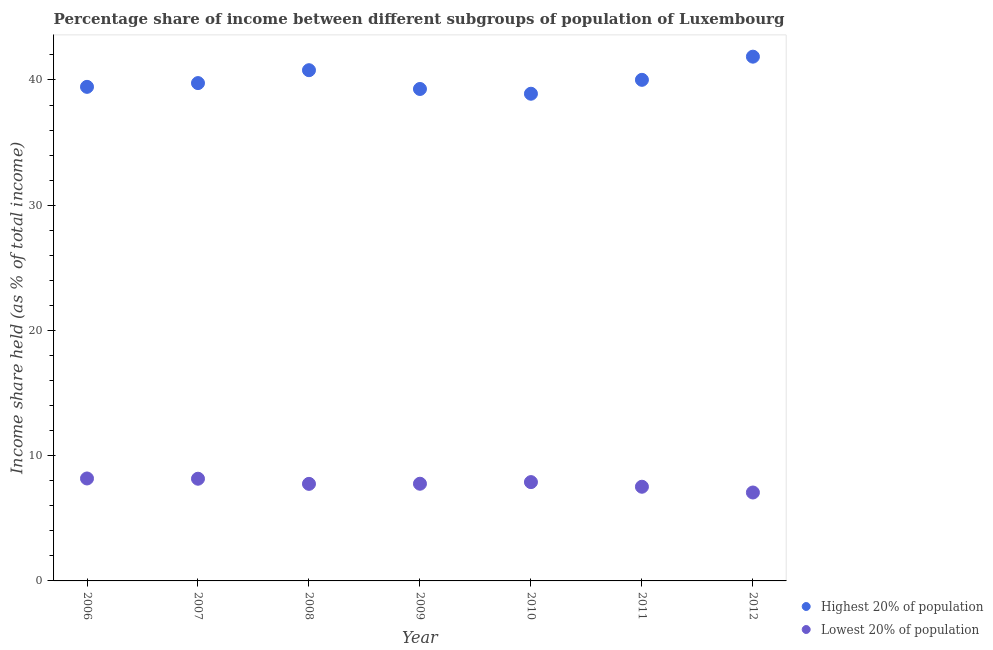What is the income share held by lowest 20% of the population in 2012?
Make the answer very short. 7.06. Across all years, what is the maximum income share held by lowest 20% of the population?
Offer a very short reply. 8.18. Across all years, what is the minimum income share held by highest 20% of the population?
Offer a terse response. 38.9. In which year was the income share held by highest 20% of the population maximum?
Your answer should be compact. 2012. In which year was the income share held by highest 20% of the population minimum?
Provide a short and direct response. 2010. What is the total income share held by highest 20% of the population in the graph?
Your response must be concise. 280.03. What is the difference between the income share held by lowest 20% of the population in 2010 and that in 2011?
Your answer should be compact. 0.37. What is the difference between the income share held by lowest 20% of the population in 2007 and the income share held by highest 20% of the population in 2008?
Keep it short and to the point. -32.62. What is the average income share held by highest 20% of the population per year?
Make the answer very short. 40. In the year 2006, what is the difference between the income share held by highest 20% of the population and income share held by lowest 20% of the population?
Your answer should be compact. 31.27. What is the ratio of the income share held by highest 20% of the population in 2007 to that in 2011?
Keep it short and to the point. 0.99. What is the difference between the highest and the second highest income share held by lowest 20% of the population?
Make the answer very short. 0.02. What is the difference between the highest and the lowest income share held by highest 20% of the population?
Offer a very short reply. 2.96. In how many years, is the income share held by highest 20% of the population greater than the average income share held by highest 20% of the population taken over all years?
Provide a short and direct response. 3. Does the income share held by highest 20% of the population monotonically increase over the years?
Your response must be concise. No. Is the income share held by highest 20% of the population strictly greater than the income share held by lowest 20% of the population over the years?
Give a very brief answer. Yes. Is the income share held by lowest 20% of the population strictly less than the income share held by highest 20% of the population over the years?
Your answer should be compact. Yes. What is the difference between two consecutive major ticks on the Y-axis?
Provide a short and direct response. 10. Are the values on the major ticks of Y-axis written in scientific E-notation?
Offer a very short reply. No. Does the graph contain any zero values?
Ensure brevity in your answer.  No. Where does the legend appear in the graph?
Offer a very short reply. Bottom right. What is the title of the graph?
Keep it short and to the point. Percentage share of income between different subgroups of population of Luxembourg. Does "Secondary Education" appear as one of the legend labels in the graph?
Offer a very short reply. No. What is the label or title of the X-axis?
Provide a succinct answer. Year. What is the label or title of the Y-axis?
Ensure brevity in your answer.  Income share held (as % of total income). What is the Income share held (as % of total income) in Highest 20% of population in 2006?
Provide a succinct answer. 39.45. What is the Income share held (as % of total income) in Lowest 20% of population in 2006?
Provide a succinct answer. 8.18. What is the Income share held (as % of total income) of Highest 20% of population in 2007?
Your answer should be compact. 39.75. What is the Income share held (as % of total income) in Lowest 20% of population in 2007?
Your answer should be very brief. 8.16. What is the Income share held (as % of total income) in Highest 20% of population in 2008?
Your response must be concise. 40.78. What is the Income share held (as % of total income) in Lowest 20% of population in 2008?
Your answer should be very brief. 7.75. What is the Income share held (as % of total income) of Highest 20% of population in 2009?
Provide a short and direct response. 39.28. What is the Income share held (as % of total income) of Lowest 20% of population in 2009?
Keep it short and to the point. 7.76. What is the Income share held (as % of total income) in Highest 20% of population in 2010?
Keep it short and to the point. 38.9. What is the Income share held (as % of total income) in Lowest 20% of population in 2010?
Provide a short and direct response. 7.89. What is the Income share held (as % of total income) of Highest 20% of population in 2011?
Make the answer very short. 40.01. What is the Income share held (as % of total income) of Lowest 20% of population in 2011?
Make the answer very short. 7.52. What is the Income share held (as % of total income) of Highest 20% of population in 2012?
Offer a terse response. 41.86. What is the Income share held (as % of total income) in Lowest 20% of population in 2012?
Your answer should be very brief. 7.06. Across all years, what is the maximum Income share held (as % of total income) in Highest 20% of population?
Offer a terse response. 41.86. Across all years, what is the maximum Income share held (as % of total income) in Lowest 20% of population?
Offer a terse response. 8.18. Across all years, what is the minimum Income share held (as % of total income) in Highest 20% of population?
Offer a very short reply. 38.9. Across all years, what is the minimum Income share held (as % of total income) in Lowest 20% of population?
Provide a succinct answer. 7.06. What is the total Income share held (as % of total income) of Highest 20% of population in the graph?
Provide a succinct answer. 280.03. What is the total Income share held (as % of total income) in Lowest 20% of population in the graph?
Keep it short and to the point. 54.32. What is the difference between the Income share held (as % of total income) of Lowest 20% of population in 2006 and that in 2007?
Your response must be concise. 0.02. What is the difference between the Income share held (as % of total income) in Highest 20% of population in 2006 and that in 2008?
Offer a terse response. -1.33. What is the difference between the Income share held (as % of total income) of Lowest 20% of population in 2006 and that in 2008?
Keep it short and to the point. 0.43. What is the difference between the Income share held (as % of total income) of Highest 20% of population in 2006 and that in 2009?
Ensure brevity in your answer.  0.17. What is the difference between the Income share held (as % of total income) of Lowest 20% of population in 2006 and that in 2009?
Your answer should be very brief. 0.42. What is the difference between the Income share held (as % of total income) of Highest 20% of population in 2006 and that in 2010?
Offer a terse response. 0.55. What is the difference between the Income share held (as % of total income) in Lowest 20% of population in 2006 and that in 2010?
Keep it short and to the point. 0.29. What is the difference between the Income share held (as % of total income) in Highest 20% of population in 2006 and that in 2011?
Give a very brief answer. -0.56. What is the difference between the Income share held (as % of total income) in Lowest 20% of population in 2006 and that in 2011?
Give a very brief answer. 0.66. What is the difference between the Income share held (as % of total income) of Highest 20% of population in 2006 and that in 2012?
Your answer should be compact. -2.41. What is the difference between the Income share held (as % of total income) of Lowest 20% of population in 2006 and that in 2012?
Offer a terse response. 1.12. What is the difference between the Income share held (as % of total income) in Highest 20% of population in 2007 and that in 2008?
Your answer should be compact. -1.03. What is the difference between the Income share held (as % of total income) of Lowest 20% of population in 2007 and that in 2008?
Offer a terse response. 0.41. What is the difference between the Income share held (as % of total income) of Highest 20% of population in 2007 and that in 2009?
Ensure brevity in your answer.  0.47. What is the difference between the Income share held (as % of total income) in Lowest 20% of population in 2007 and that in 2009?
Your answer should be compact. 0.4. What is the difference between the Income share held (as % of total income) of Lowest 20% of population in 2007 and that in 2010?
Your answer should be very brief. 0.27. What is the difference between the Income share held (as % of total income) of Highest 20% of population in 2007 and that in 2011?
Your answer should be very brief. -0.26. What is the difference between the Income share held (as % of total income) in Lowest 20% of population in 2007 and that in 2011?
Keep it short and to the point. 0.64. What is the difference between the Income share held (as % of total income) of Highest 20% of population in 2007 and that in 2012?
Offer a very short reply. -2.11. What is the difference between the Income share held (as % of total income) in Lowest 20% of population in 2007 and that in 2012?
Give a very brief answer. 1.1. What is the difference between the Income share held (as % of total income) in Highest 20% of population in 2008 and that in 2009?
Provide a short and direct response. 1.5. What is the difference between the Income share held (as % of total income) in Lowest 20% of population in 2008 and that in 2009?
Provide a succinct answer. -0.01. What is the difference between the Income share held (as % of total income) in Highest 20% of population in 2008 and that in 2010?
Your answer should be compact. 1.88. What is the difference between the Income share held (as % of total income) of Lowest 20% of population in 2008 and that in 2010?
Your response must be concise. -0.14. What is the difference between the Income share held (as % of total income) in Highest 20% of population in 2008 and that in 2011?
Keep it short and to the point. 0.77. What is the difference between the Income share held (as % of total income) in Lowest 20% of population in 2008 and that in 2011?
Give a very brief answer. 0.23. What is the difference between the Income share held (as % of total income) of Highest 20% of population in 2008 and that in 2012?
Give a very brief answer. -1.08. What is the difference between the Income share held (as % of total income) of Lowest 20% of population in 2008 and that in 2012?
Keep it short and to the point. 0.69. What is the difference between the Income share held (as % of total income) in Highest 20% of population in 2009 and that in 2010?
Give a very brief answer. 0.38. What is the difference between the Income share held (as % of total income) in Lowest 20% of population in 2009 and that in 2010?
Your answer should be compact. -0.13. What is the difference between the Income share held (as % of total income) of Highest 20% of population in 2009 and that in 2011?
Keep it short and to the point. -0.73. What is the difference between the Income share held (as % of total income) in Lowest 20% of population in 2009 and that in 2011?
Your answer should be very brief. 0.24. What is the difference between the Income share held (as % of total income) in Highest 20% of population in 2009 and that in 2012?
Offer a very short reply. -2.58. What is the difference between the Income share held (as % of total income) of Highest 20% of population in 2010 and that in 2011?
Offer a terse response. -1.11. What is the difference between the Income share held (as % of total income) in Lowest 20% of population in 2010 and that in 2011?
Provide a short and direct response. 0.37. What is the difference between the Income share held (as % of total income) of Highest 20% of population in 2010 and that in 2012?
Offer a terse response. -2.96. What is the difference between the Income share held (as % of total income) in Lowest 20% of population in 2010 and that in 2012?
Your response must be concise. 0.83. What is the difference between the Income share held (as % of total income) of Highest 20% of population in 2011 and that in 2012?
Offer a terse response. -1.85. What is the difference between the Income share held (as % of total income) of Lowest 20% of population in 2011 and that in 2012?
Provide a succinct answer. 0.46. What is the difference between the Income share held (as % of total income) of Highest 20% of population in 2006 and the Income share held (as % of total income) of Lowest 20% of population in 2007?
Provide a succinct answer. 31.29. What is the difference between the Income share held (as % of total income) of Highest 20% of population in 2006 and the Income share held (as % of total income) of Lowest 20% of population in 2008?
Your answer should be compact. 31.7. What is the difference between the Income share held (as % of total income) of Highest 20% of population in 2006 and the Income share held (as % of total income) of Lowest 20% of population in 2009?
Offer a very short reply. 31.69. What is the difference between the Income share held (as % of total income) in Highest 20% of population in 2006 and the Income share held (as % of total income) in Lowest 20% of population in 2010?
Your answer should be compact. 31.56. What is the difference between the Income share held (as % of total income) of Highest 20% of population in 2006 and the Income share held (as % of total income) of Lowest 20% of population in 2011?
Provide a succinct answer. 31.93. What is the difference between the Income share held (as % of total income) in Highest 20% of population in 2006 and the Income share held (as % of total income) in Lowest 20% of population in 2012?
Ensure brevity in your answer.  32.39. What is the difference between the Income share held (as % of total income) in Highest 20% of population in 2007 and the Income share held (as % of total income) in Lowest 20% of population in 2009?
Ensure brevity in your answer.  31.99. What is the difference between the Income share held (as % of total income) in Highest 20% of population in 2007 and the Income share held (as % of total income) in Lowest 20% of population in 2010?
Your response must be concise. 31.86. What is the difference between the Income share held (as % of total income) in Highest 20% of population in 2007 and the Income share held (as % of total income) in Lowest 20% of population in 2011?
Provide a short and direct response. 32.23. What is the difference between the Income share held (as % of total income) in Highest 20% of population in 2007 and the Income share held (as % of total income) in Lowest 20% of population in 2012?
Your answer should be very brief. 32.69. What is the difference between the Income share held (as % of total income) of Highest 20% of population in 2008 and the Income share held (as % of total income) of Lowest 20% of population in 2009?
Keep it short and to the point. 33.02. What is the difference between the Income share held (as % of total income) in Highest 20% of population in 2008 and the Income share held (as % of total income) in Lowest 20% of population in 2010?
Your response must be concise. 32.89. What is the difference between the Income share held (as % of total income) of Highest 20% of population in 2008 and the Income share held (as % of total income) of Lowest 20% of population in 2011?
Ensure brevity in your answer.  33.26. What is the difference between the Income share held (as % of total income) in Highest 20% of population in 2008 and the Income share held (as % of total income) in Lowest 20% of population in 2012?
Your answer should be very brief. 33.72. What is the difference between the Income share held (as % of total income) of Highest 20% of population in 2009 and the Income share held (as % of total income) of Lowest 20% of population in 2010?
Ensure brevity in your answer.  31.39. What is the difference between the Income share held (as % of total income) in Highest 20% of population in 2009 and the Income share held (as % of total income) in Lowest 20% of population in 2011?
Make the answer very short. 31.76. What is the difference between the Income share held (as % of total income) of Highest 20% of population in 2009 and the Income share held (as % of total income) of Lowest 20% of population in 2012?
Provide a succinct answer. 32.22. What is the difference between the Income share held (as % of total income) of Highest 20% of population in 2010 and the Income share held (as % of total income) of Lowest 20% of population in 2011?
Provide a short and direct response. 31.38. What is the difference between the Income share held (as % of total income) of Highest 20% of population in 2010 and the Income share held (as % of total income) of Lowest 20% of population in 2012?
Keep it short and to the point. 31.84. What is the difference between the Income share held (as % of total income) of Highest 20% of population in 2011 and the Income share held (as % of total income) of Lowest 20% of population in 2012?
Your answer should be compact. 32.95. What is the average Income share held (as % of total income) in Highest 20% of population per year?
Provide a short and direct response. 40. What is the average Income share held (as % of total income) in Lowest 20% of population per year?
Provide a succinct answer. 7.76. In the year 2006, what is the difference between the Income share held (as % of total income) in Highest 20% of population and Income share held (as % of total income) in Lowest 20% of population?
Keep it short and to the point. 31.27. In the year 2007, what is the difference between the Income share held (as % of total income) of Highest 20% of population and Income share held (as % of total income) of Lowest 20% of population?
Offer a very short reply. 31.59. In the year 2008, what is the difference between the Income share held (as % of total income) in Highest 20% of population and Income share held (as % of total income) in Lowest 20% of population?
Keep it short and to the point. 33.03. In the year 2009, what is the difference between the Income share held (as % of total income) of Highest 20% of population and Income share held (as % of total income) of Lowest 20% of population?
Your answer should be very brief. 31.52. In the year 2010, what is the difference between the Income share held (as % of total income) of Highest 20% of population and Income share held (as % of total income) of Lowest 20% of population?
Provide a succinct answer. 31.01. In the year 2011, what is the difference between the Income share held (as % of total income) in Highest 20% of population and Income share held (as % of total income) in Lowest 20% of population?
Your answer should be compact. 32.49. In the year 2012, what is the difference between the Income share held (as % of total income) in Highest 20% of population and Income share held (as % of total income) in Lowest 20% of population?
Offer a very short reply. 34.8. What is the ratio of the Income share held (as % of total income) in Highest 20% of population in 2006 to that in 2008?
Keep it short and to the point. 0.97. What is the ratio of the Income share held (as % of total income) in Lowest 20% of population in 2006 to that in 2008?
Keep it short and to the point. 1.06. What is the ratio of the Income share held (as % of total income) in Lowest 20% of population in 2006 to that in 2009?
Ensure brevity in your answer.  1.05. What is the ratio of the Income share held (as % of total income) of Highest 20% of population in 2006 to that in 2010?
Your answer should be very brief. 1.01. What is the ratio of the Income share held (as % of total income) in Lowest 20% of population in 2006 to that in 2010?
Your answer should be very brief. 1.04. What is the ratio of the Income share held (as % of total income) of Lowest 20% of population in 2006 to that in 2011?
Your answer should be very brief. 1.09. What is the ratio of the Income share held (as % of total income) of Highest 20% of population in 2006 to that in 2012?
Your answer should be compact. 0.94. What is the ratio of the Income share held (as % of total income) of Lowest 20% of population in 2006 to that in 2012?
Offer a terse response. 1.16. What is the ratio of the Income share held (as % of total income) of Highest 20% of population in 2007 to that in 2008?
Keep it short and to the point. 0.97. What is the ratio of the Income share held (as % of total income) in Lowest 20% of population in 2007 to that in 2008?
Keep it short and to the point. 1.05. What is the ratio of the Income share held (as % of total income) in Highest 20% of population in 2007 to that in 2009?
Ensure brevity in your answer.  1.01. What is the ratio of the Income share held (as % of total income) in Lowest 20% of population in 2007 to that in 2009?
Offer a very short reply. 1.05. What is the ratio of the Income share held (as % of total income) in Highest 20% of population in 2007 to that in 2010?
Offer a terse response. 1.02. What is the ratio of the Income share held (as % of total income) of Lowest 20% of population in 2007 to that in 2010?
Your response must be concise. 1.03. What is the ratio of the Income share held (as % of total income) in Lowest 20% of population in 2007 to that in 2011?
Offer a terse response. 1.09. What is the ratio of the Income share held (as % of total income) of Highest 20% of population in 2007 to that in 2012?
Keep it short and to the point. 0.95. What is the ratio of the Income share held (as % of total income) of Lowest 20% of population in 2007 to that in 2012?
Keep it short and to the point. 1.16. What is the ratio of the Income share held (as % of total income) of Highest 20% of population in 2008 to that in 2009?
Keep it short and to the point. 1.04. What is the ratio of the Income share held (as % of total income) of Lowest 20% of population in 2008 to that in 2009?
Your answer should be compact. 1. What is the ratio of the Income share held (as % of total income) in Highest 20% of population in 2008 to that in 2010?
Your answer should be compact. 1.05. What is the ratio of the Income share held (as % of total income) of Lowest 20% of population in 2008 to that in 2010?
Offer a very short reply. 0.98. What is the ratio of the Income share held (as % of total income) in Highest 20% of population in 2008 to that in 2011?
Your answer should be compact. 1.02. What is the ratio of the Income share held (as % of total income) of Lowest 20% of population in 2008 to that in 2011?
Your answer should be compact. 1.03. What is the ratio of the Income share held (as % of total income) in Highest 20% of population in 2008 to that in 2012?
Your answer should be compact. 0.97. What is the ratio of the Income share held (as % of total income) in Lowest 20% of population in 2008 to that in 2012?
Your answer should be very brief. 1.1. What is the ratio of the Income share held (as % of total income) of Highest 20% of population in 2009 to that in 2010?
Ensure brevity in your answer.  1.01. What is the ratio of the Income share held (as % of total income) of Lowest 20% of population in 2009 to that in 2010?
Give a very brief answer. 0.98. What is the ratio of the Income share held (as % of total income) of Highest 20% of population in 2009 to that in 2011?
Provide a succinct answer. 0.98. What is the ratio of the Income share held (as % of total income) of Lowest 20% of population in 2009 to that in 2011?
Keep it short and to the point. 1.03. What is the ratio of the Income share held (as % of total income) of Highest 20% of population in 2009 to that in 2012?
Provide a succinct answer. 0.94. What is the ratio of the Income share held (as % of total income) of Lowest 20% of population in 2009 to that in 2012?
Give a very brief answer. 1.1. What is the ratio of the Income share held (as % of total income) of Highest 20% of population in 2010 to that in 2011?
Provide a succinct answer. 0.97. What is the ratio of the Income share held (as % of total income) in Lowest 20% of population in 2010 to that in 2011?
Your answer should be compact. 1.05. What is the ratio of the Income share held (as % of total income) in Highest 20% of population in 2010 to that in 2012?
Your answer should be compact. 0.93. What is the ratio of the Income share held (as % of total income) of Lowest 20% of population in 2010 to that in 2012?
Your response must be concise. 1.12. What is the ratio of the Income share held (as % of total income) in Highest 20% of population in 2011 to that in 2012?
Ensure brevity in your answer.  0.96. What is the ratio of the Income share held (as % of total income) of Lowest 20% of population in 2011 to that in 2012?
Provide a succinct answer. 1.07. What is the difference between the highest and the second highest Income share held (as % of total income) in Highest 20% of population?
Offer a very short reply. 1.08. What is the difference between the highest and the lowest Income share held (as % of total income) in Highest 20% of population?
Your answer should be compact. 2.96. What is the difference between the highest and the lowest Income share held (as % of total income) in Lowest 20% of population?
Provide a succinct answer. 1.12. 